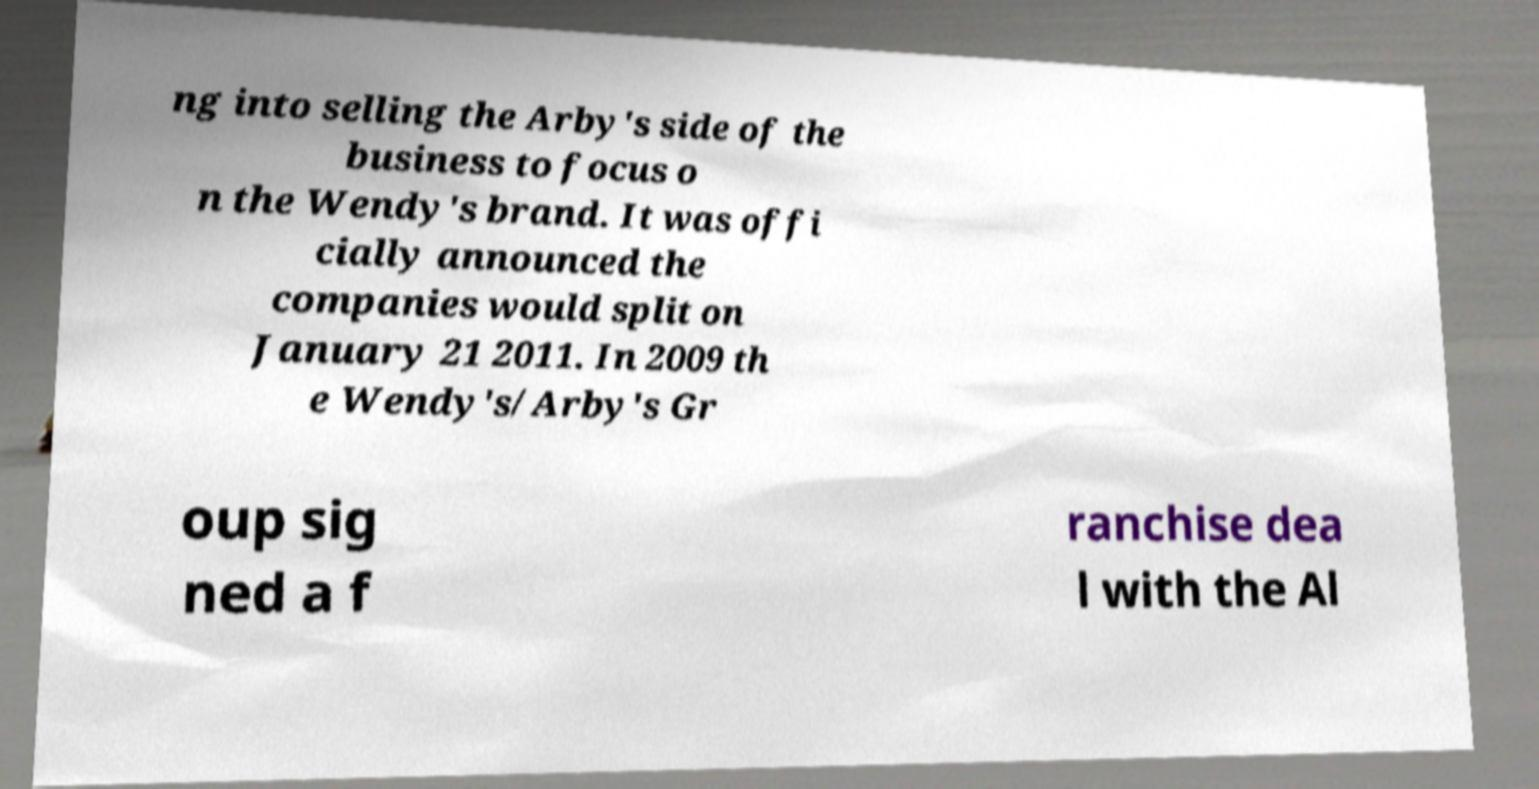What messages or text are displayed in this image? I need them in a readable, typed format. ng into selling the Arby's side of the business to focus o n the Wendy's brand. It was offi cially announced the companies would split on January 21 2011. In 2009 th e Wendy's/Arby's Gr oup sig ned a f ranchise dea l with the Al 